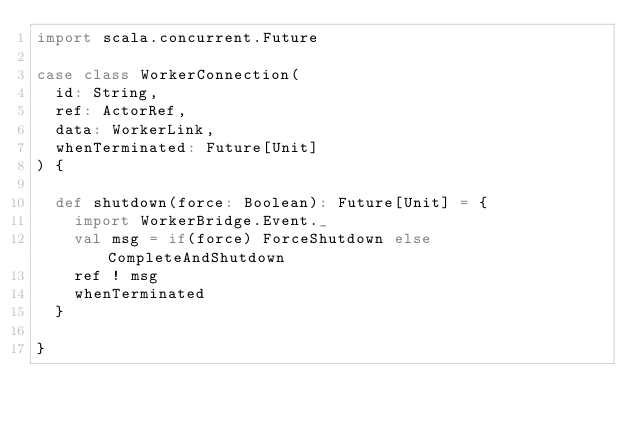<code> <loc_0><loc_0><loc_500><loc_500><_Scala_>import scala.concurrent.Future

case class WorkerConnection(
  id: String,
  ref: ActorRef,
  data: WorkerLink,
  whenTerminated: Future[Unit]
) {

  def shutdown(force: Boolean): Future[Unit] = {
    import WorkerBridge.Event._
    val msg = if(force) ForceShutdown else CompleteAndShutdown
    ref ! msg
    whenTerminated
  }

}

</code> 